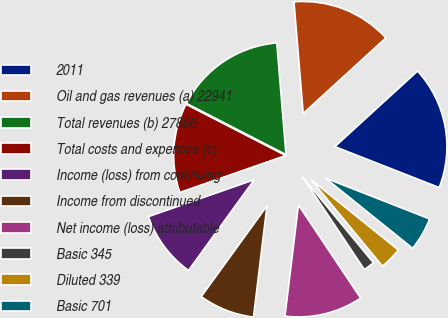Convert chart to OTSL. <chart><loc_0><loc_0><loc_500><loc_500><pie_chart><fcel>2011<fcel>Oil and gas revenues (a) 22941<fcel>Total revenues (b) 27866<fcel>Total costs and expenses (c)<fcel>Income (loss) from continuing<fcel>Income from discontinued<fcel>Net income (loss) attributable<fcel>Basic 345<fcel>Diluted 339<fcel>Basic 701<nl><fcel>17.74%<fcel>14.52%<fcel>16.13%<fcel>12.9%<fcel>9.68%<fcel>8.06%<fcel>11.29%<fcel>1.61%<fcel>3.23%<fcel>4.84%<nl></chart> 